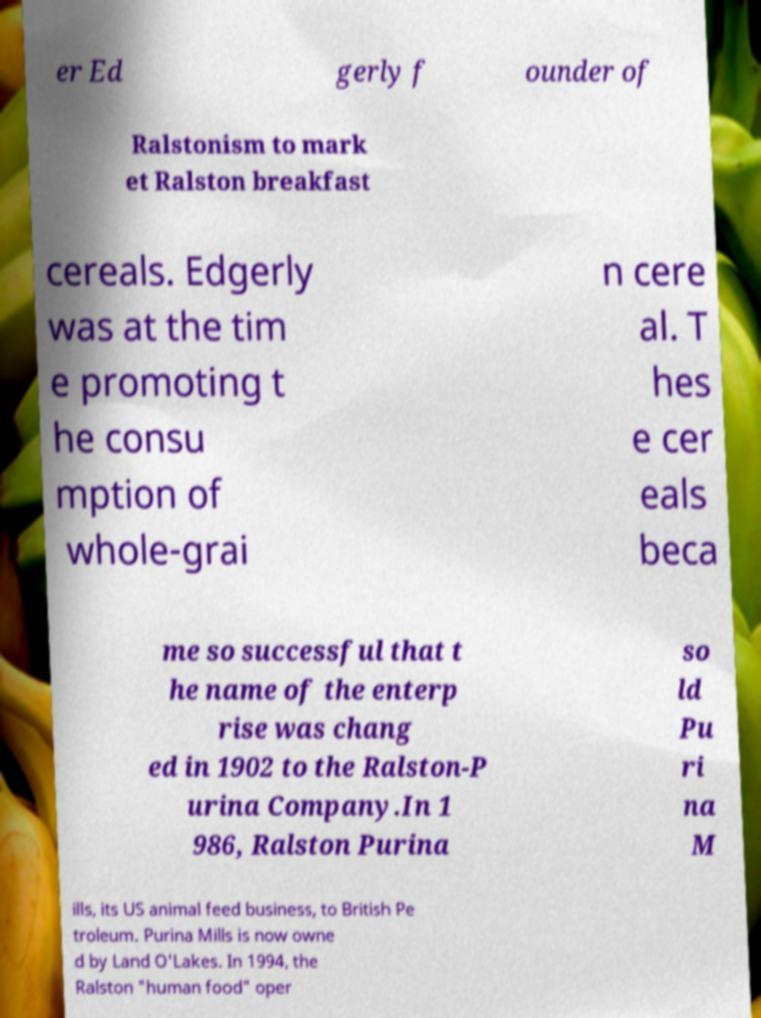Could you assist in decoding the text presented in this image and type it out clearly? er Ed gerly f ounder of Ralstonism to mark et Ralston breakfast cereals. Edgerly was at the tim e promoting t he consu mption of whole-grai n cere al. T hes e cer eals beca me so successful that t he name of the enterp rise was chang ed in 1902 to the Ralston-P urina Company.In 1 986, Ralston Purina so ld Pu ri na M ills, its US animal feed business, to British Pe troleum. Purina Mills is now owne d by Land O'Lakes. In 1994, the Ralston "human food" oper 